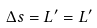Convert formula to latex. <formula><loc_0><loc_0><loc_500><loc_500>\Delta s = L ^ { \prime } = L ^ { \prime }</formula> 